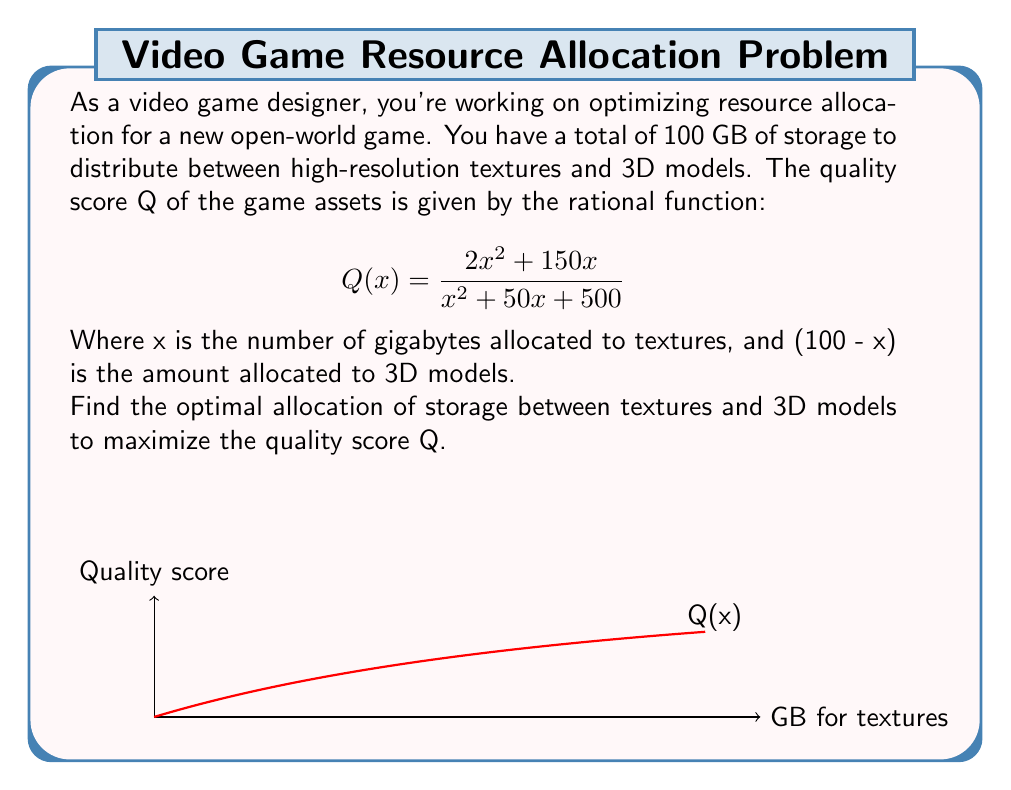Teach me how to tackle this problem. To find the optimal allocation, we need to find the maximum value of Q(x) in the domain [0, 100].

Step 1: Find the derivative of Q(x).
$$Q'(x) = \frac{(x^2 + 50x + 500)(4x + 150) - (2x^2 + 150x)(2x + 50)}{(x^2 + 50x + 500)^2}$$

Step 2: Simplify the numerator of Q'(x).
$$Q'(x) = \frac{4x^3 + 200x^2 + 2000x + 150x^2 + 7500x + 37500 - 4x^3 - 100x^2 - 300x^2 - 7500x}{(x^2 + 50x + 500)^2}$$
$$Q'(x) = \frac{-50x^2 + 2000x + 37500}{(x^2 + 50x + 500)^2}$$

Step 3: Set Q'(x) = 0 and solve for x.
$$-50x^2 + 2000x + 37500 = 0$$
$$x^2 - 40x - 750 = 0$$
$$(x - 50)(x + 10) = 0$$
$$x = 50 \text{ or } x = -10$$

Step 4: Check the endpoints and the critical point within the domain [0, 100].
Q(0) ≈ 0
Q(50) ≈ 1.67
Q(100) ≈ 1.54

Step 5: Verify that x = 50 is indeed a maximum by checking the sign of Q'(x) around x = 50.

The maximum quality score occurs when x = 50.
Answer: 50 GB for textures, 50 GB for 3D models 